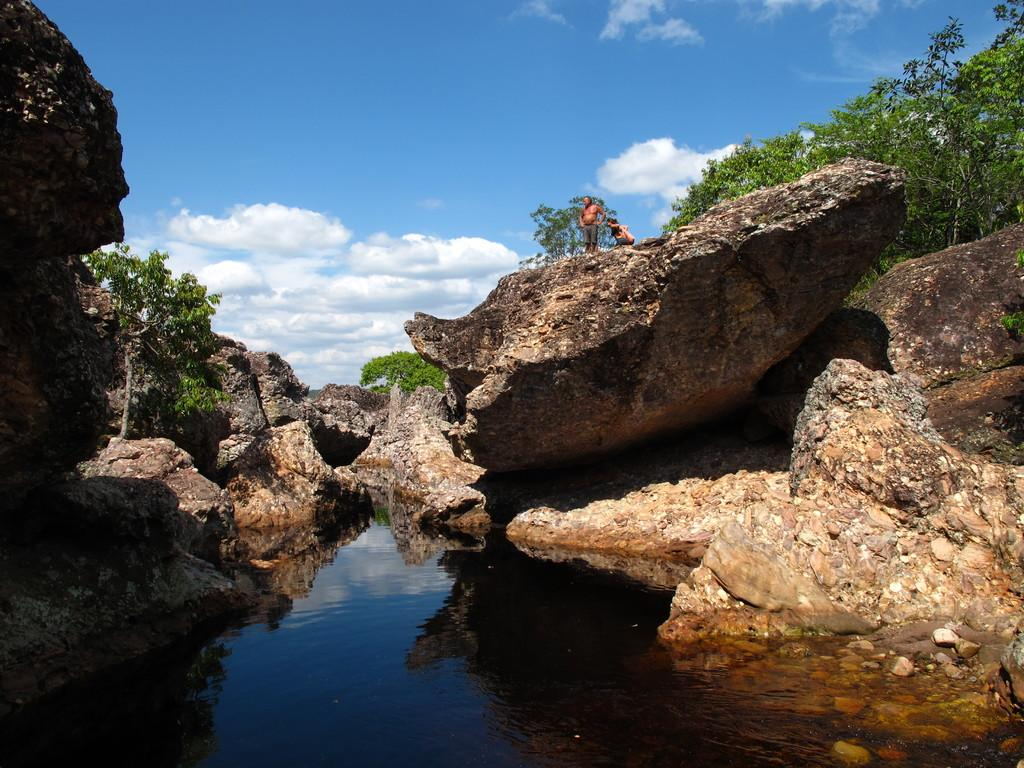How many people are in the image? There are two persons in the image. What is visible in the image besides the people? Water, rocks, trees, and the sky are visible in the image. Can you describe the natural environment in the image? The image features water, rocks, and trees, which are elements of a natural environment. What is visible in the background of the image? The sky is visible in the background of the image. What type of pain is the person experiencing in the image? There is no indication in the image that anyone is experiencing pain, so it cannot be determined from the picture. 